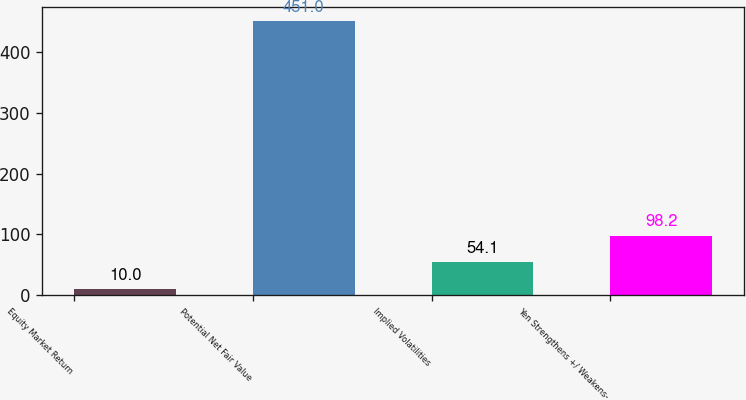Convert chart to OTSL. <chart><loc_0><loc_0><loc_500><loc_500><bar_chart><fcel>Equity Market Return<fcel>Potential Net Fair Value<fcel>Implied Volatilities<fcel>Yen Strengthens +/ Weakens-<nl><fcel>10<fcel>451<fcel>54.1<fcel>98.2<nl></chart> 